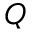<formula> <loc_0><loc_0><loc_500><loc_500>Q</formula> 